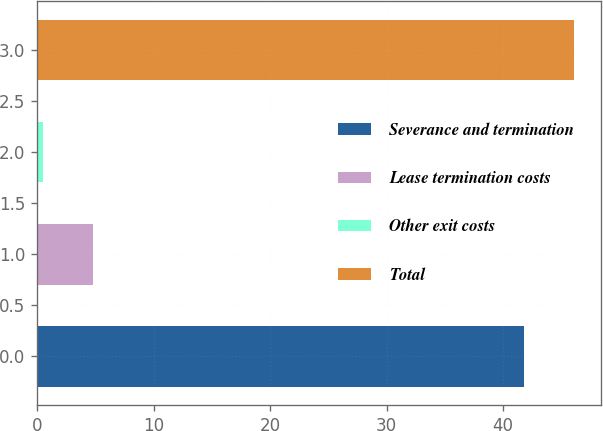Convert chart. <chart><loc_0><loc_0><loc_500><loc_500><bar_chart><fcel>Severance and termination<fcel>Lease termination costs<fcel>Other exit costs<fcel>Total<nl><fcel>41.8<fcel>4.8<fcel>0.5<fcel>46.1<nl></chart> 